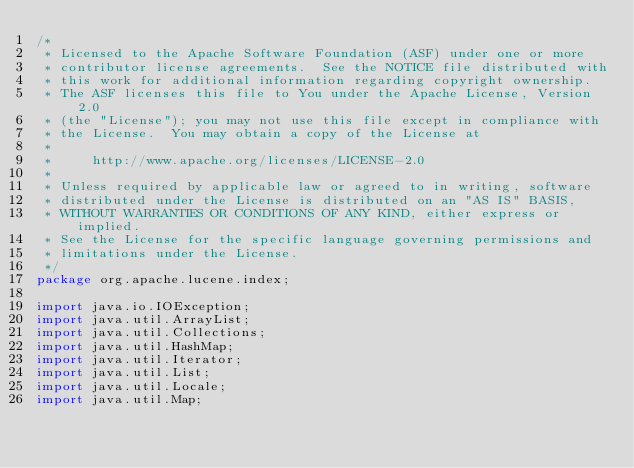Convert code to text. <code><loc_0><loc_0><loc_500><loc_500><_Java_>/*
 * Licensed to the Apache Software Foundation (ASF) under one or more
 * contributor license agreements.  See the NOTICE file distributed with
 * this work for additional information regarding copyright ownership.
 * The ASF licenses this file to You under the Apache License, Version 2.0
 * (the "License"); you may not use this file except in compliance with
 * the License.  You may obtain a copy of the License at
 *
 *     http://www.apache.org/licenses/LICENSE-2.0
 *
 * Unless required by applicable law or agreed to in writing, software
 * distributed under the License is distributed on an "AS IS" BASIS,
 * WITHOUT WARRANTIES OR CONDITIONS OF ANY KIND, either express or implied.
 * See the License for the specific language governing permissions and
 * limitations under the License.
 */
package org.apache.lucene.index;

import java.io.IOException;
import java.util.ArrayList;
import java.util.Collections;
import java.util.HashMap;
import java.util.Iterator;
import java.util.List;
import java.util.Locale;
import java.util.Map;</code> 